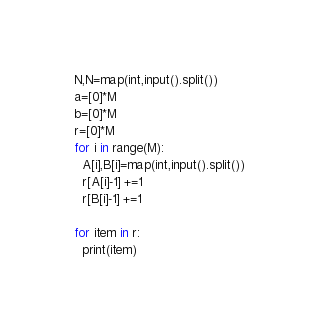<code> <loc_0><loc_0><loc_500><loc_500><_Python_>N,N=map(int,input().split())
a=[0]*M
b=[0]*M
r=[0]*M
for i in range(M):
  A[i],B[i]=map(int,input().split())
  r[A[i]-1] +=1
  r[B[i]-1] +=1
  
for item in r:
  print(item)</code> 